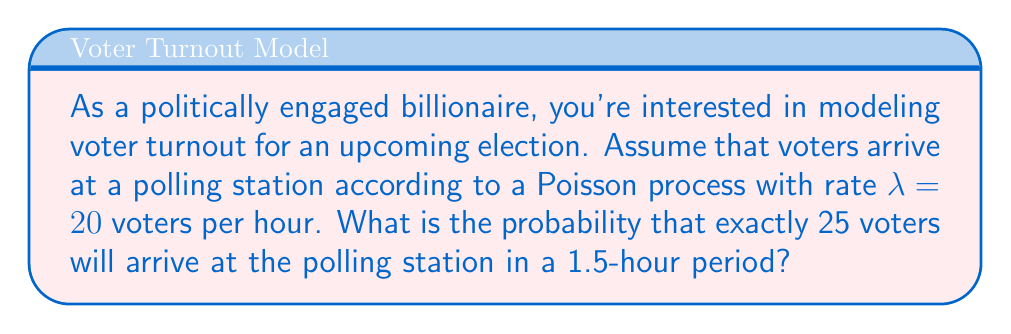Help me with this question. Let's approach this step-by-step:

1) In a Poisson process, the number of events (in this case, voters arriving) in a fixed time interval follows a Poisson distribution.

2) The Poisson distribution is characterized by its rate parameter, which is the average number of events in the given time interval.

3) We're given that $\lambda = 20$ voters per hour. However, we're interested in a 1.5-hour period. So we need to adjust our rate:

   $\lambda_{1.5 hours} = 20 \times 1.5 = 30$ voters

4) The probability mass function for a Poisson distribution is:

   $$P(X = k) = \frac{e^{-\lambda}\lambda^k}{k!}$$

   where $X$ is the number of events, $k$ is the specific number we're interested in, $\lambda$ is the rate, and $e$ is Euler's number.

5) We want $P(X = 25)$ with $\lambda = 30$:

   $$P(X = 25) = \frac{e^{-30}30^{25}}{25!}$$

6) Calculating this (using a calculator or computer due to the large numbers involved):

   $$P(X = 25) \approx 0.0561$$

Thus, the probability of exactly 25 voters arriving in a 1.5-hour period is approximately 0.0561 or 5.61%.
Answer: 0.0561 